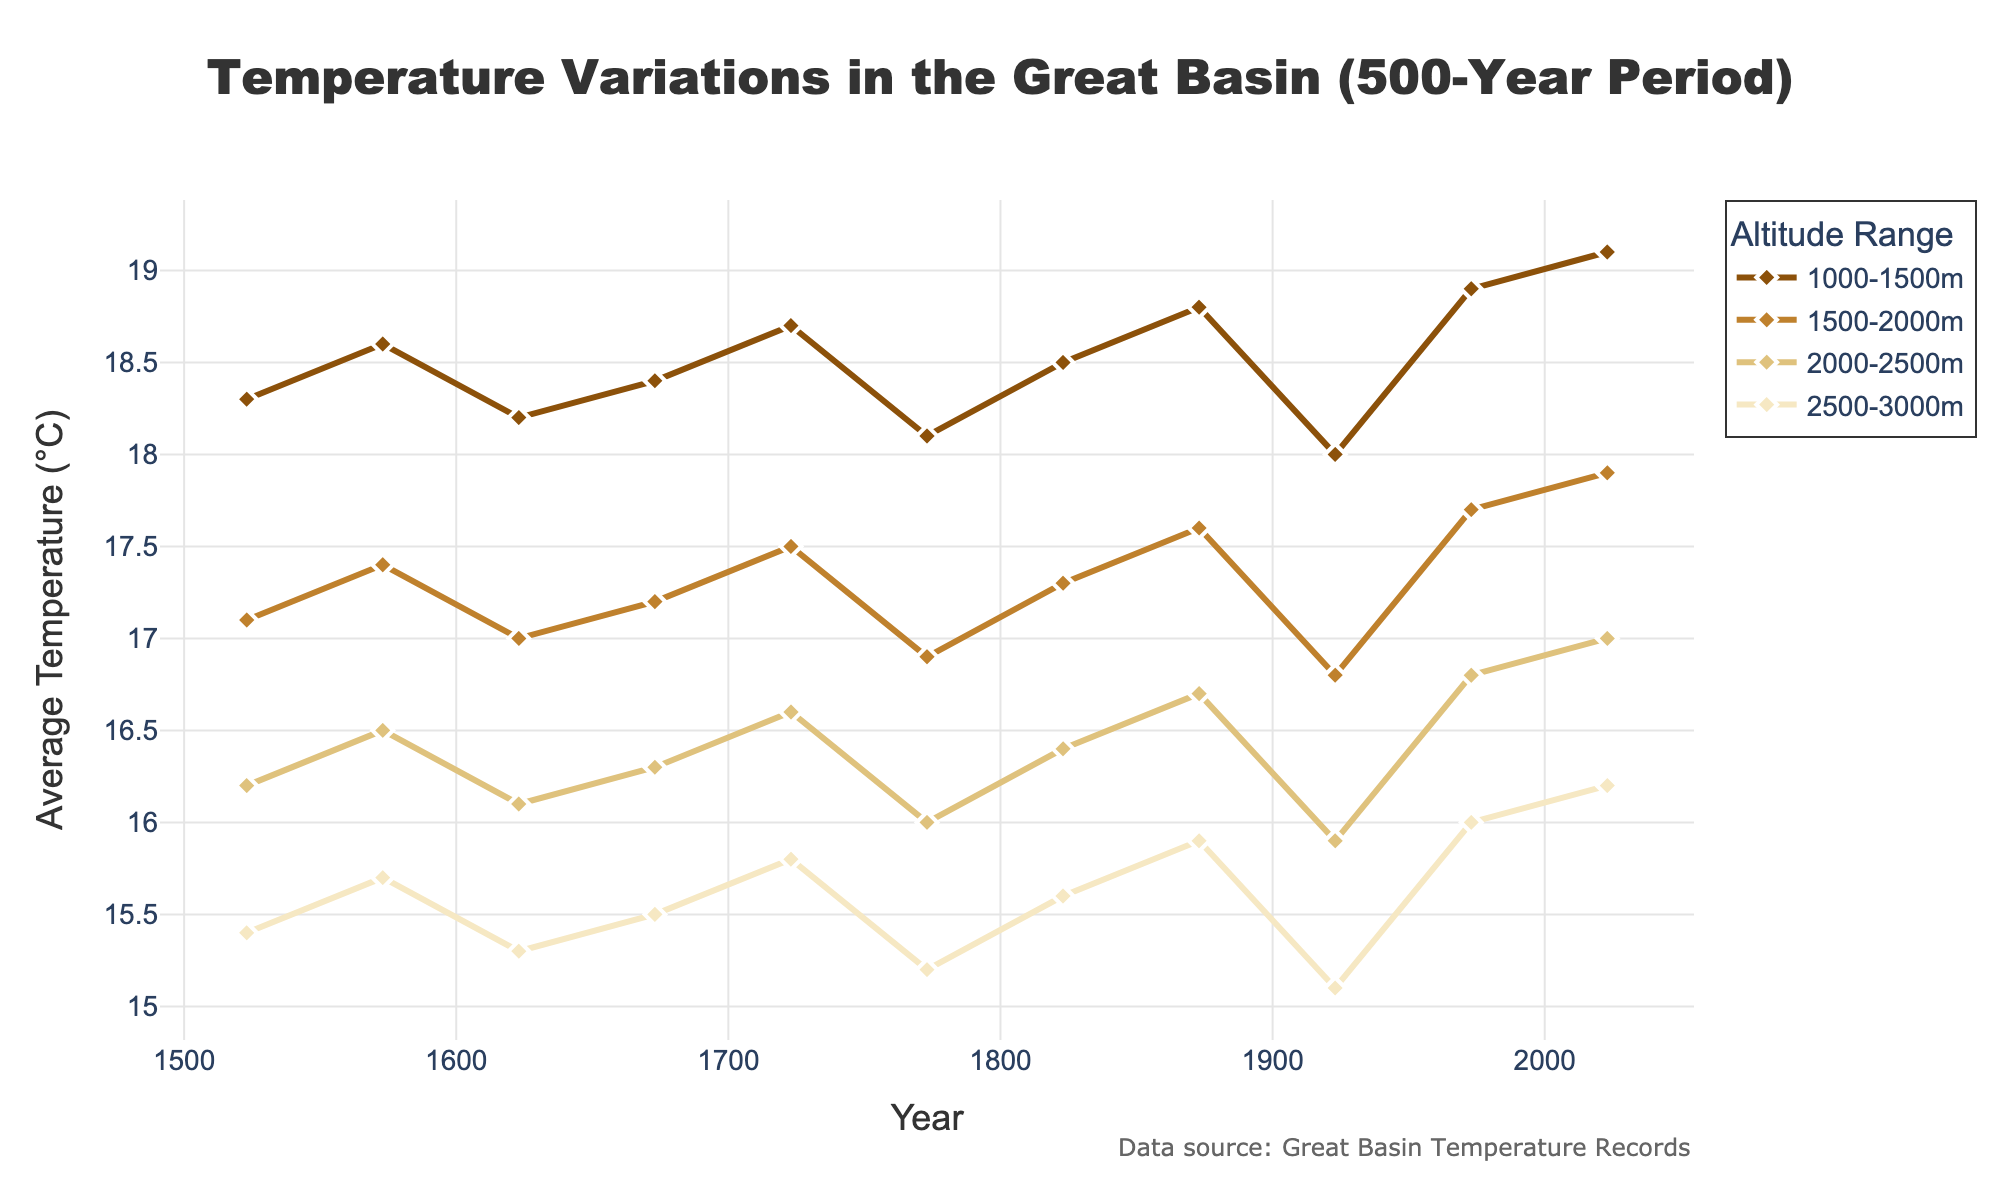What is the average temperature at the 2000-2500m altitude range in the year 1523? Look at the plot, find the altitude range 2000-2500m, then find the point for the year 1523 on the x-axis and read the temperature value at that point.
Answer: 16.2°C How does the average temperature change from 1523 to 2023 at 1500-2000m altitude? Identify the temperature values for the year 1523 and 2023 at the 1500-2000m altitude range in the plot. Subtract the value in 1523 from the value in 2023 to get the difference.
Answer: +0.8°C Which altitude range had the highest increase in average temperature from 1523 to 2023? Compare the temperature values across all altitude ranges for the years 1523 and 2023 in the plot. Calculate the increase for each range and identify the highest one.
Answer: 1000-1500m What is the general trend of temperature variation in the Great Basin over the 500 years? Observe the overall direction of the lines across all altitude ranges. If they generally show an upward or downward trend over time, that indicates the trend of temperature variation.
Answer: Upward trend Which year had the lowest average temperature at 2500-3000m altitude? Look at the temperature values for the 2500-3000m altitude range in the plot, and identify the lowest value and its corresponding year.
Answer: 1923 Between 1873 and 1923, which altitude range shows the smallest change in temperature? Calculate the temperature change between 1873 and 1923 for each altitude range by subtracting the values for 1923 from 1873. Compare these changes and find the smallest one.
Answer: 2500-3000m At which altitude range is the average temperature in 1973 closest to the average temperature in 1623 at 1000-1500m altitude? Find the temperature value for 1623 at 1000-1500m altitude, then look at the temperature values for 1973 at all other altitude ranges. Compare these values and identify which one is closest.
Answer: 1500-2000m How much did the temperature at 2000-2500m altitude increase between 1923 and 2023? Locate the temperature values for 1923 and 2023 at the 2000-2500m altitude range in the plot. Subtract the value for 1923 from the value for 2023.
Answer: 1.1°C Which altitude range had the most fluctuating average temperatures over the 500-year period? Look at the variability in the plotted lines for all altitude ranges. Identify which line shows the most ups and downs over time.
Answer: 1500-2000m How many distinct altitude ranges are presented in the figure? Count the number of unique traces or labeled lines representing altitude ranges in the plot.
Answer: Four 